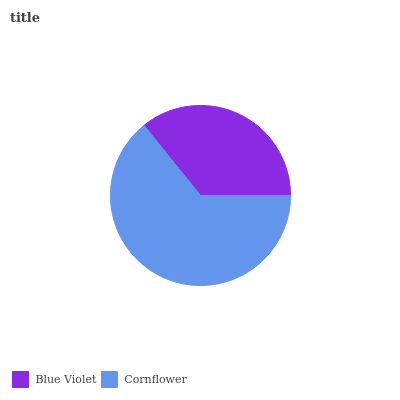Is Blue Violet the minimum?
Answer yes or no. Yes. Is Cornflower the maximum?
Answer yes or no. Yes. Is Cornflower the minimum?
Answer yes or no. No. Is Cornflower greater than Blue Violet?
Answer yes or no. Yes. Is Blue Violet less than Cornflower?
Answer yes or no. Yes. Is Blue Violet greater than Cornflower?
Answer yes or no. No. Is Cornflower less than Blue Violet?
Answer yes or no. No. Is Cornflower the high median?
Answer yes or no. Yes. Is Blue Violet the low median?
Answer yes or no. Yes. Is Blue Violet the high median?
Answer yes or no. No. Is Cornflower the low median?
Answer yes or no. No. 